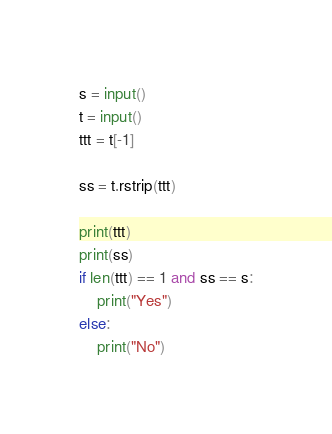<code> <loc_0><loc_0><loc_500><loc_500><_Python_>s = input()
t = input()
ttt = t[-1]

ss = t.rstrip(ttt)

print(ttt)
print(ss)
if len(ttt) == 1 and ss == s:
    print("Yes")
else:
    print("No")
</code> 